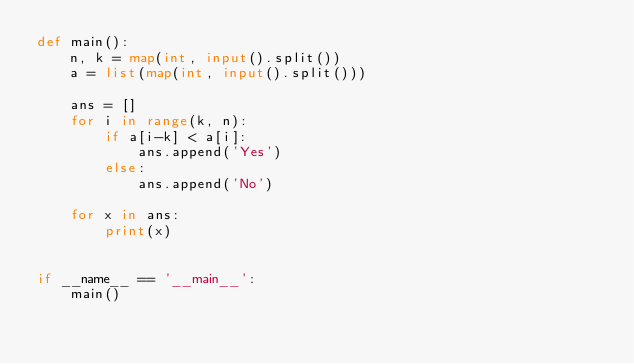Convert code to text. <code><loc_0><loc_0><loc_500><loc_500><_Python_>def main():
    n, k = map(int, input().split())
    a = list(map(int, input().split()))

    ans = []
    for i in range(k, n):
        if a[i-k] < a[i]:
            ans.append('Yes')
        else:
            ans.append('No')

    for x in ans:
        print(x)


if __name__ == '__main__':
    main()
</code> 